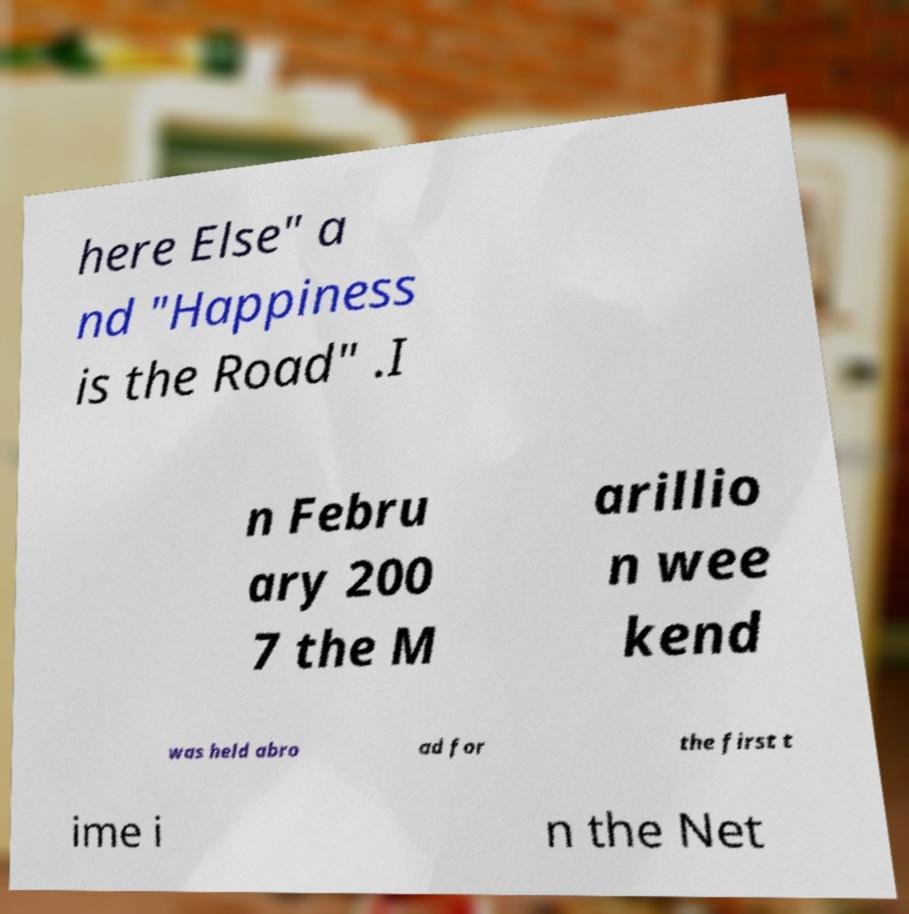I need the written content from this picture converted into text. Can you do that? here Else" a nd "Happiness is the Road" .I n Febru ary 200 7 the M arillio n wee kend was held abro ad for the first t ime i n the Net 